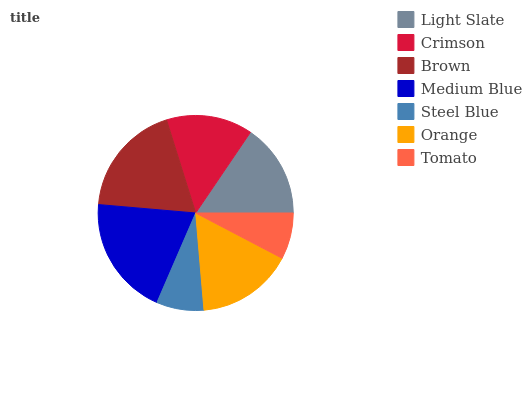Is Tomato the minimum?
Answer yes or no. Yes. Is Medium Blue the maximum?
Answer yes or no. Yes. Is Crimson the minimum?
Answer yes or no. No. Is Crimson the maximum?
Answer yes or no. No. Is Light Slate greater than Crimson?
Answer yes or no. Yes. Is Crimson less than Light Slate?
Answer yes or no. Yes. Is Crimson greater than Light Slate?
Answer yes or no. No. Is Light Slate less than Crimson?
Answer yes or no. No. Is Light Slate the high median?
Answer yes or no. Yes. Is Light Slate the low median?
Answer yes or no. Yes. Is Steel Blue the high median?
Answer yes or no. No. Is Orange the low median?
Answer yes or no. No. 